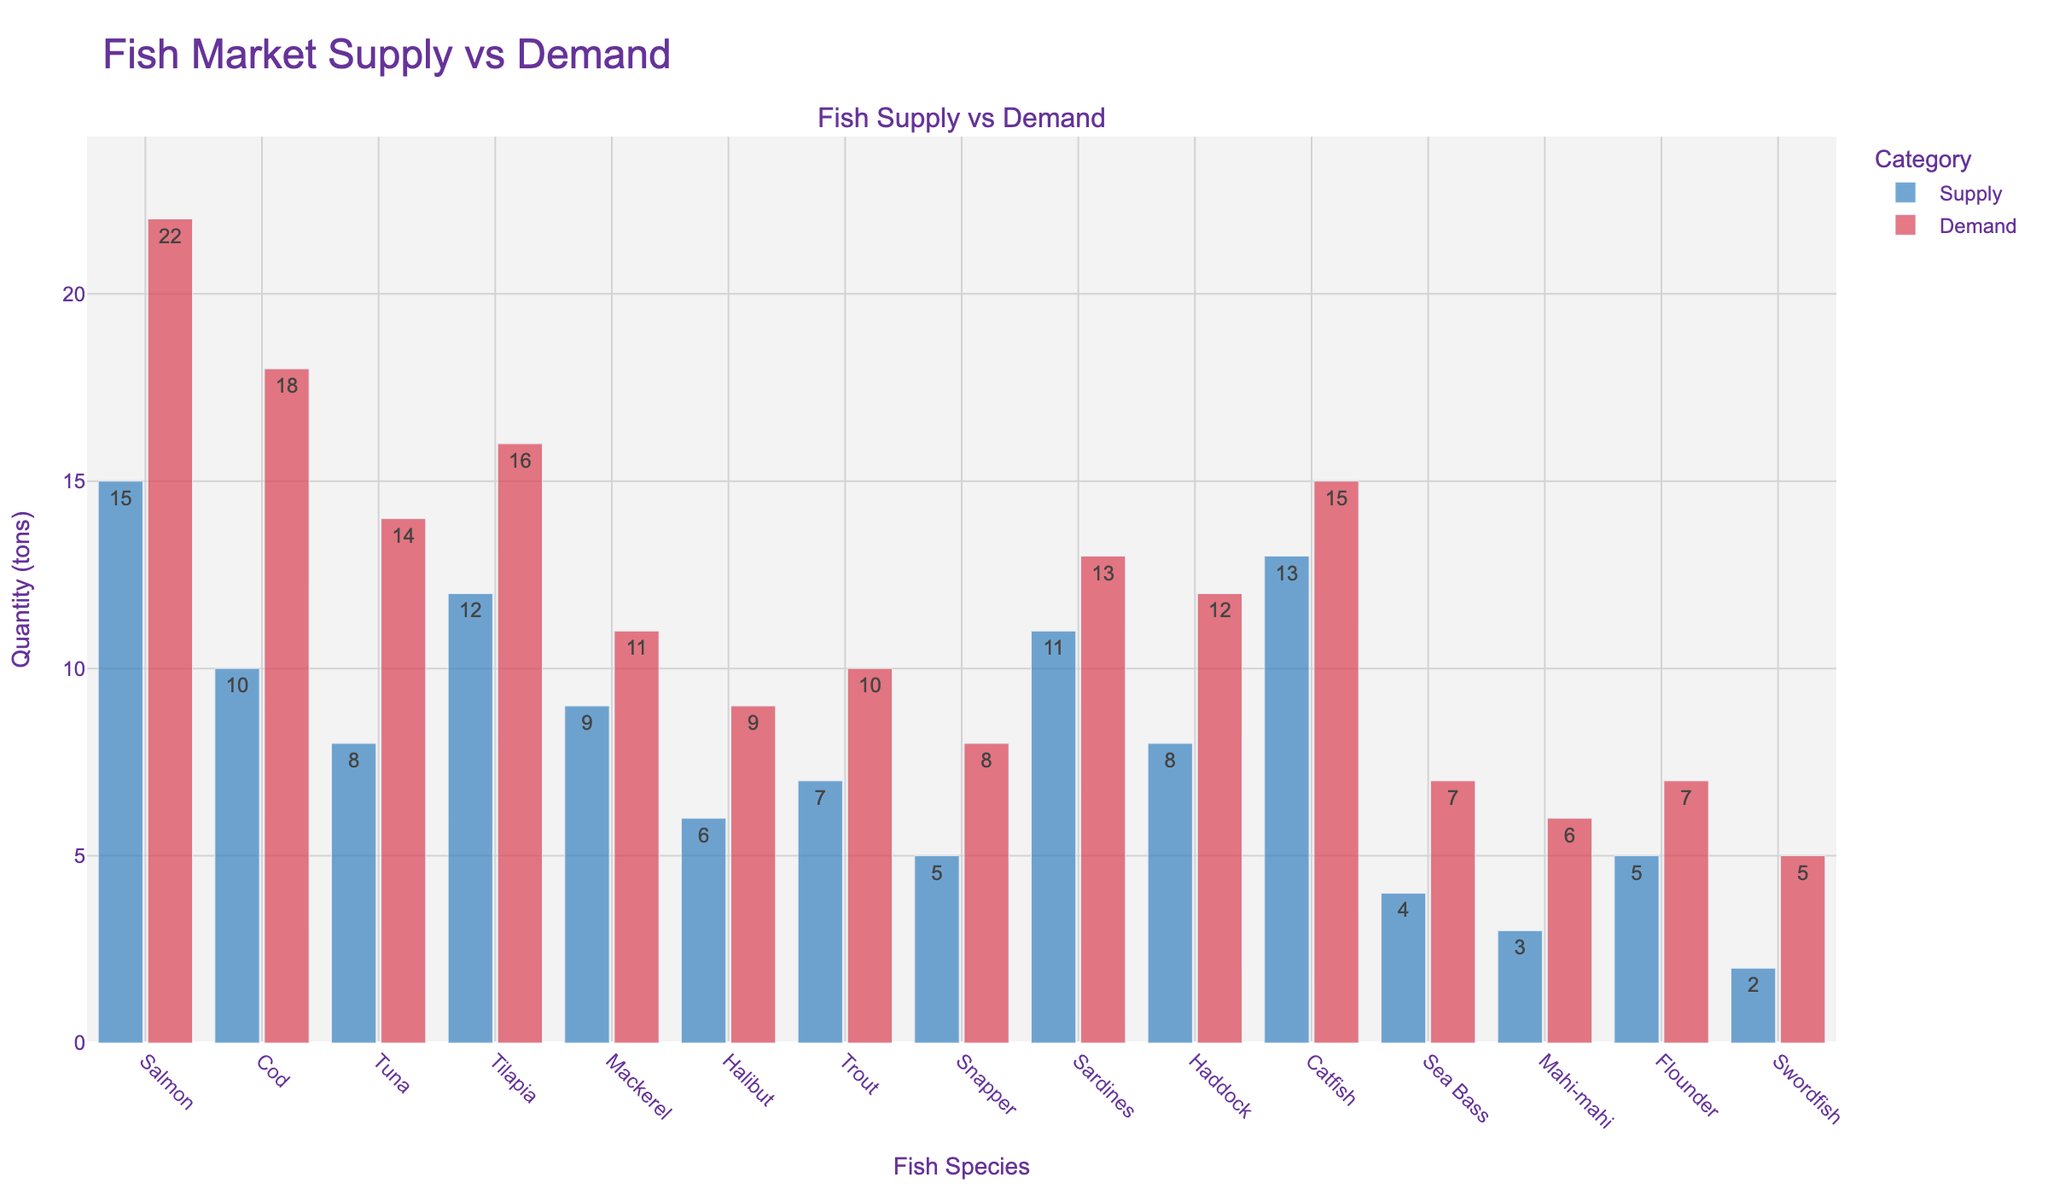Which fish species has the highest demand? The red bars represent the demand for each fish species. By locating the highest red bar, we find that Salmon has the highest demand.
Answer: Salmon Between Cod and Tuna, which has a larger supply and by how much? The blue bars represent the supply. By comparing the heights of the supply bars for Cod (10 tons) and Tuna (8 tons), Cod has a larger supply. The difference in supply is 10 - 8 = 2 tons.
Answer: Cod by 2 tons What's the total supply of Mahi-mahi and Swordfish combined? The supply for Mahi-mahi is 3 tons and for Swordfish is 2 tons. Adding them together gives 3 + 2 = 5 tons.
Answer: 5 tons Which fish species has the smallest gap between supply and demand? The gaps between the supply and demand bars are smallest for Mackerel, which has a supply of 9 tons and demand of 11 tons, resulting in a gap of 11 - 9 = 2 tons.
Answer: Mackerel What is the average demand for Snapper, Sardines, and Catfish? The demand for Snapper is 8 tons, Sardines is 13 tons, and Catfish is 15 tons. The average is calculated as (8 + 13 + 15) / 3 = 12 tons.
Answer: 12 tons How many fish species have a demand greater than 10 tons? By looking at the red bars, Salmon, Cod, Tuna, Tilapia, Sardines, Haddock, and Catfish all have demands greater than 10 tons. Counting them gives 7 species.
Answer: 7 species What is the combined difference between supply and demand for Salmon, Cod, and Tuna? Salmon has a supply of 15 tons and demand of 22 tons (22-15=7 tons), Cod has a supply of 10 tons and demand of 18 tons (18-10=8 tons), Tuna has a supply of 8 tons and demand of 14 tons (14-8=6 tons). Summing the differences gives 7 + 8 + 6 = 21 tons.
Answer: 21 tons Which fish species has the lowest supply? The blue bars represent the supply. By locating the shortest blue bar, we find that Swordfish has the lowest supply at 2 tons.
Answer: Swordfish 